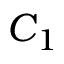Convert formula to latex. <formula><loc_0><loc_0><loc_500><loc_500>C _ { 1 }</formula> 